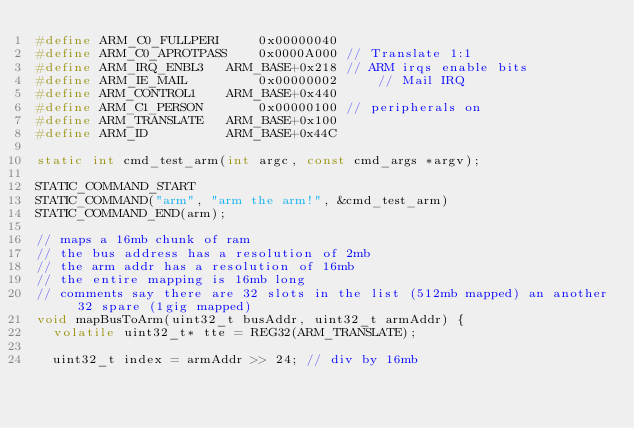<code> <loc_0><loc_0><loc_500><loc_500><_C_>#define ARM_C0_FULLPERI     0x00000040
#define ARM_C0_APROTPASS    0x0000A000 // Translate 1:1
#define ARM_IRQ_ENBL3   ARM_BASE+0x218 // ARM irqs enable bits
#define ARM_IE_MAIL         0x00000002     // Mail IRQ
#define ARM_CONTROL1    ARM_BASE+0x440
#define ARM_C1_PERSON       0x00000100 // peripherals on
#define ARM_TRANSLATE   ARM_BASE+0x100
#define ARM_ID          ARM_BASE+0x44C

static int cmd_test_arm(int argc, const cmd_args *argv);

STATIC_COMMAND_START
STATIC_COMMAND("arm", "arm the arm!", &cmd_test_arm)
STATIC_COMMAND_END(arm);

// maps a 16mb chunk of ram
// the bus address has a resolution of 2mb
// the arm addr has a resolution of 16mb
// the entire mapping is 16mb long
// comments say there are 32 slots in the list (512mb mapped) an another 32 spare (1gig mapped)
void mapBusToArm(uint32_t busAddr, uint32_t armAddr) {
  volatile uint32_t* tte = REG32(ARM_TRANSLATE);

  uint32_t index = armAddr >> 24; // div by 16mb</code> 